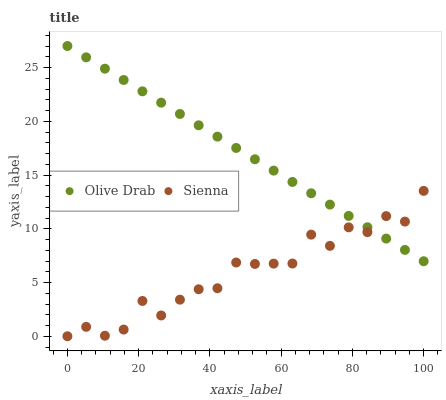Does Sienna have the minimum area under the curve?
Answer yes or no. Yes. Does Olive Drab have the maximum area under the curve?
Answer yes or no. Yes. Does Olive Drab have the minimum area under the curve?
Answer yes or no. No. Is Olive Drab the smoothest?
Answer yes or no. Yes. Is Sienna the roughest?
Answer yes or no. Yes. Is Olive Drab the roughest?
Answer yes or no. No. Does Sienna have the lowest value?
Answer yes or no. Yes. Does Olive Drab have the lowest value?
Answer yes or no. No. Does Olive Drab have the highest value?
Answer yes or no. Yes. Does Sienna intersect Olive Drab?
Answer yes or no. Yes. Is Sienna less than Olive Drab?
Answer yes or no. No. Is Sienna greater than Olive Drab?
Answer yes or no. No. 